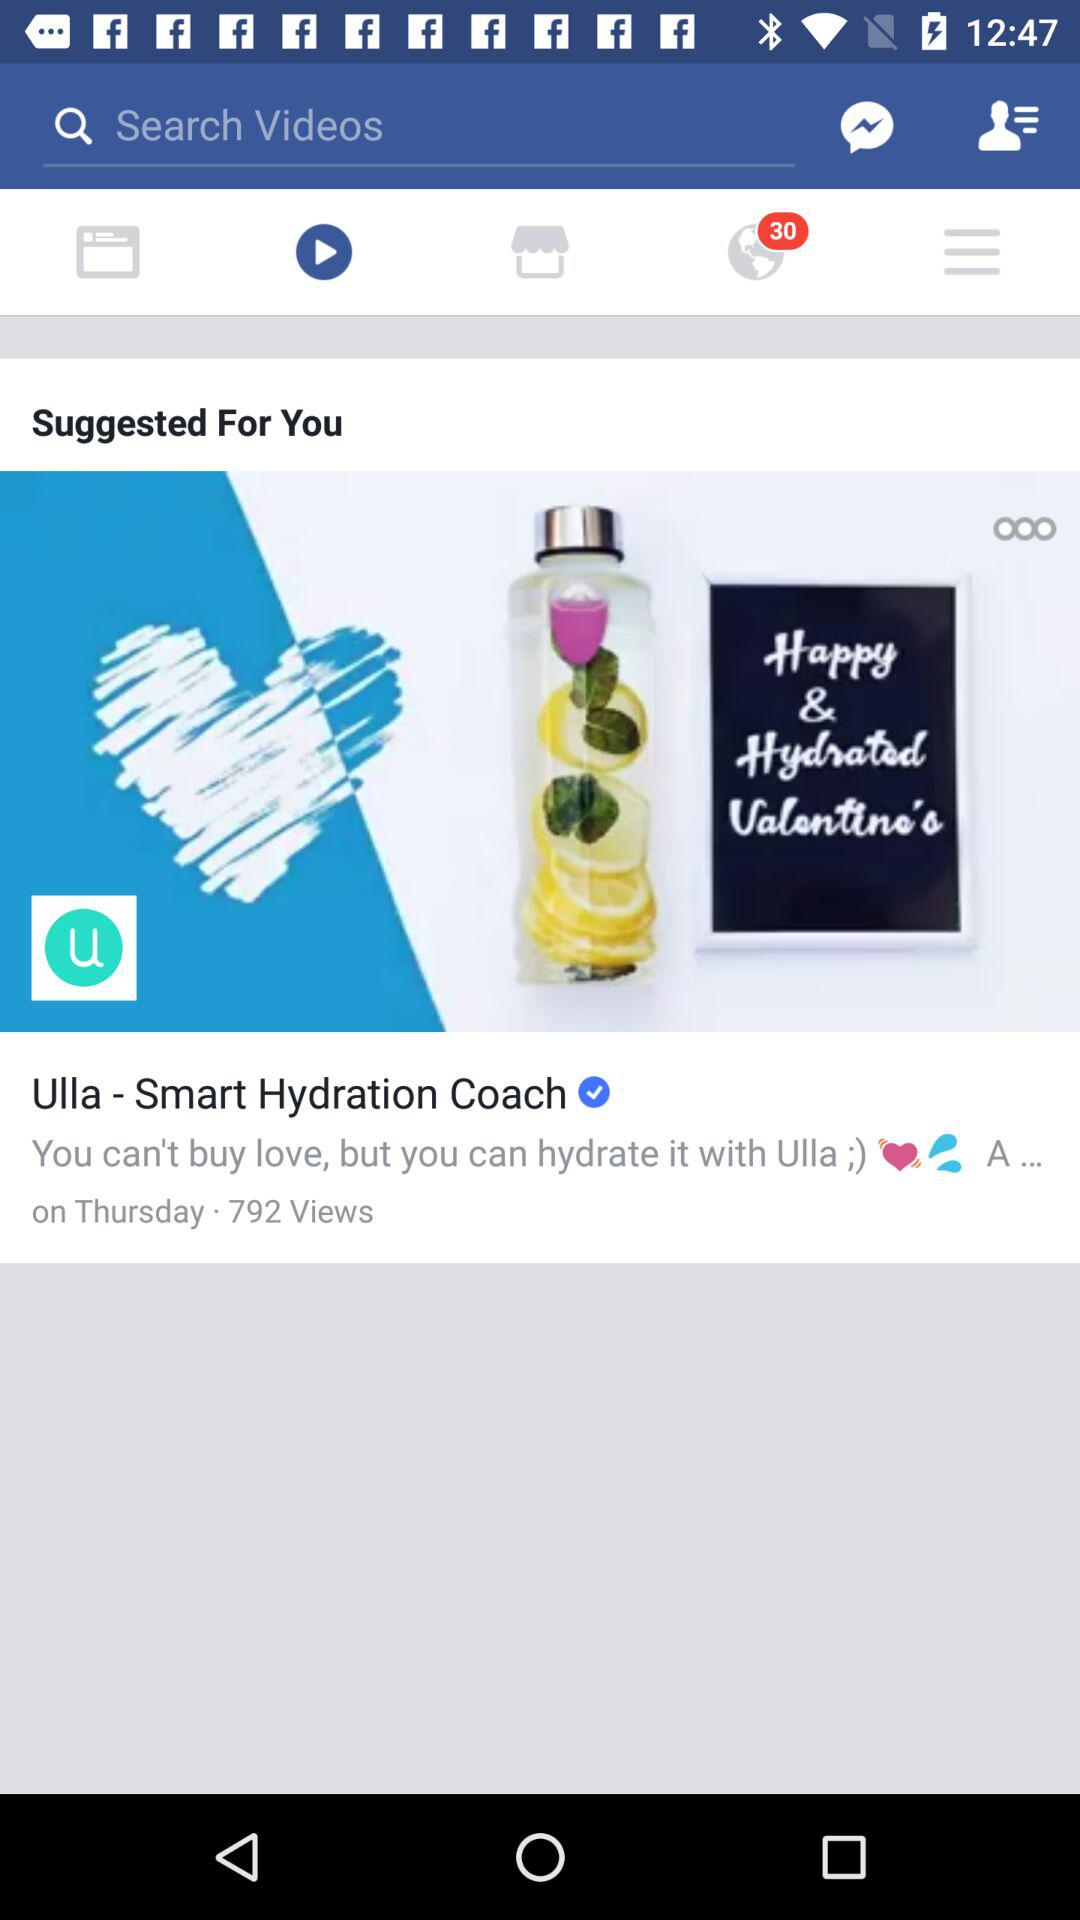What is the brand name? The brand name is Ulla. 